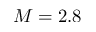<formula> <loc_0><loc_0><loc_500><loc_500>M = 2 . 8</formula> 